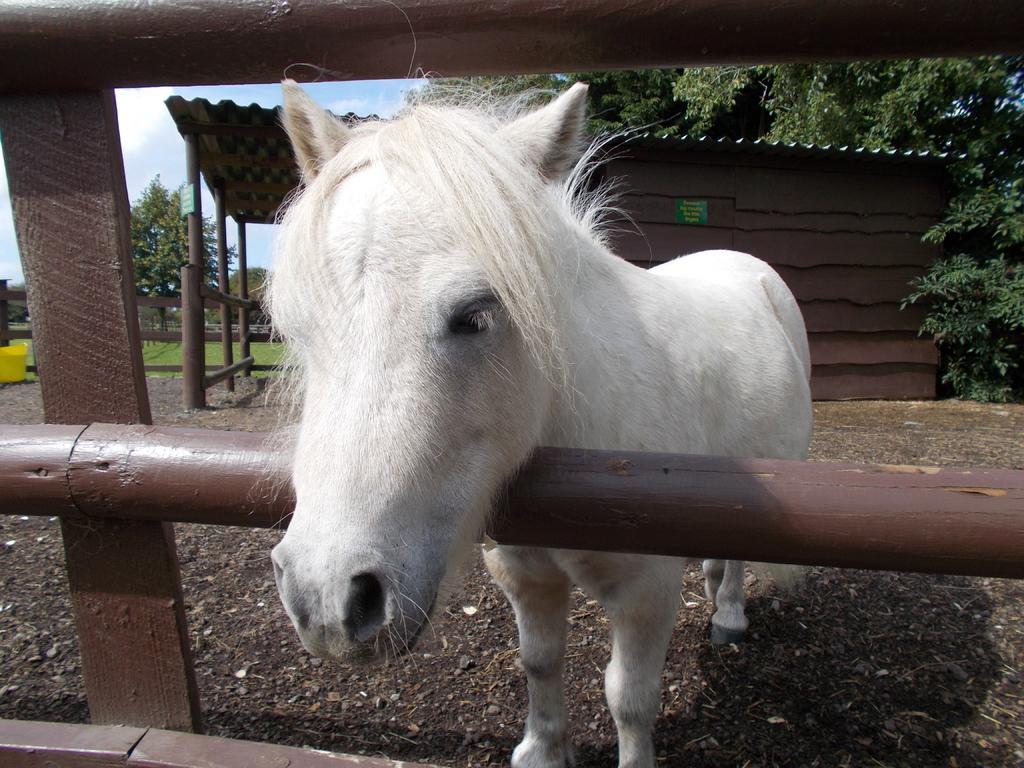Describe this image in one or two sentences. In this picture we can see a horse is standing in the front, in the background there is a house, trees and grass, there is the sky at the top of the picture, at the bottom we can see some stones. 